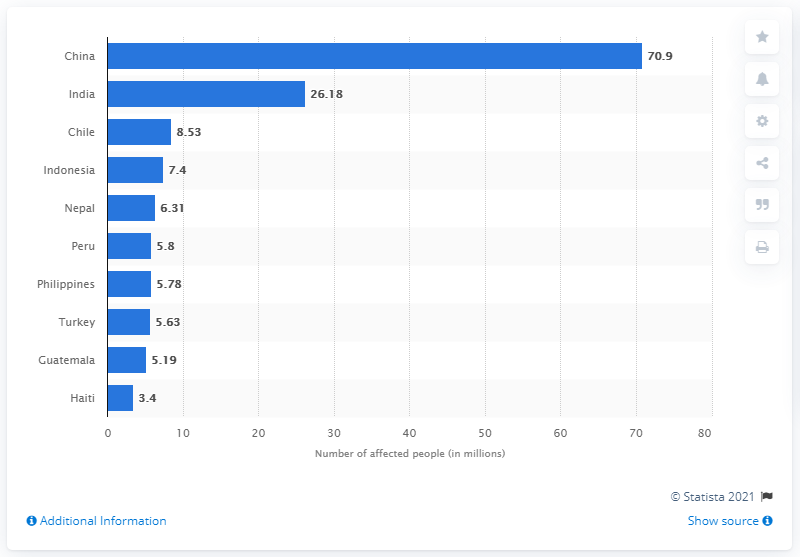Highlight a few significant elements in this photo. The country with the most affected people from earthquakes from 1900 to 2016 is China, with an estimated 13 million people impacted. According to data from 1900 to 2016, the average number of people affected by earthquakes in the country with the highest and lowest impact is 37.15 million. During the period between 1900 and 2016, earthquakes in China affected a total of 70.9 million people. 